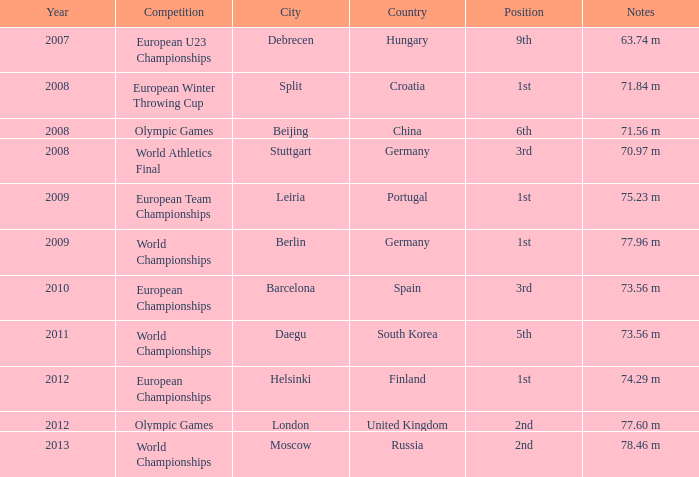Could you parse the entire table? {'header': ['Year', 'Competition', 'City', 'Country', 'Position', 'Notes'], 'rows': [['2007', 'European U23 Championships', 'Debrecen', 'Hungary', '9th', '63.74 m'], ['2008', 'European Winter Throwing Cup', 'Split', 'Croatia', '1st', '71.84 m'], ['2008', 'Olympic Games', 'Beijing', 'China', '6th', '71.56 m'], ['2008', 'World Athletics Final', 'Stuttgart', 'Germany', '3rd', '70.97 m'], ['2009', 'European Team Championships', 'Leiria', 'Portugal', '1st', '75.23 m'], ['2009', 'World Championships', 'Berlin', 'Germany', '1st', '77.96 m'], ['2010', 'European Championships', 'Barcelona', 'Spain', '3rd', '73.56 m'], ['2011', 'World Championships', 'Daegu', 'South Korea', '5th', '73.56 m'], ['2012', 'European Championships', 'Helsinki', 'Finland', '1st', '74.29 m'], ['2012', 'Olympic Games', 'London', 'United Kingdom', '2nd', '77.60 m'], ['2013', 'World Championships', 'Moscow', 'Russia', '2nd', '78.46 m']]} Which Year has a Position of 9th? 2007.0. 